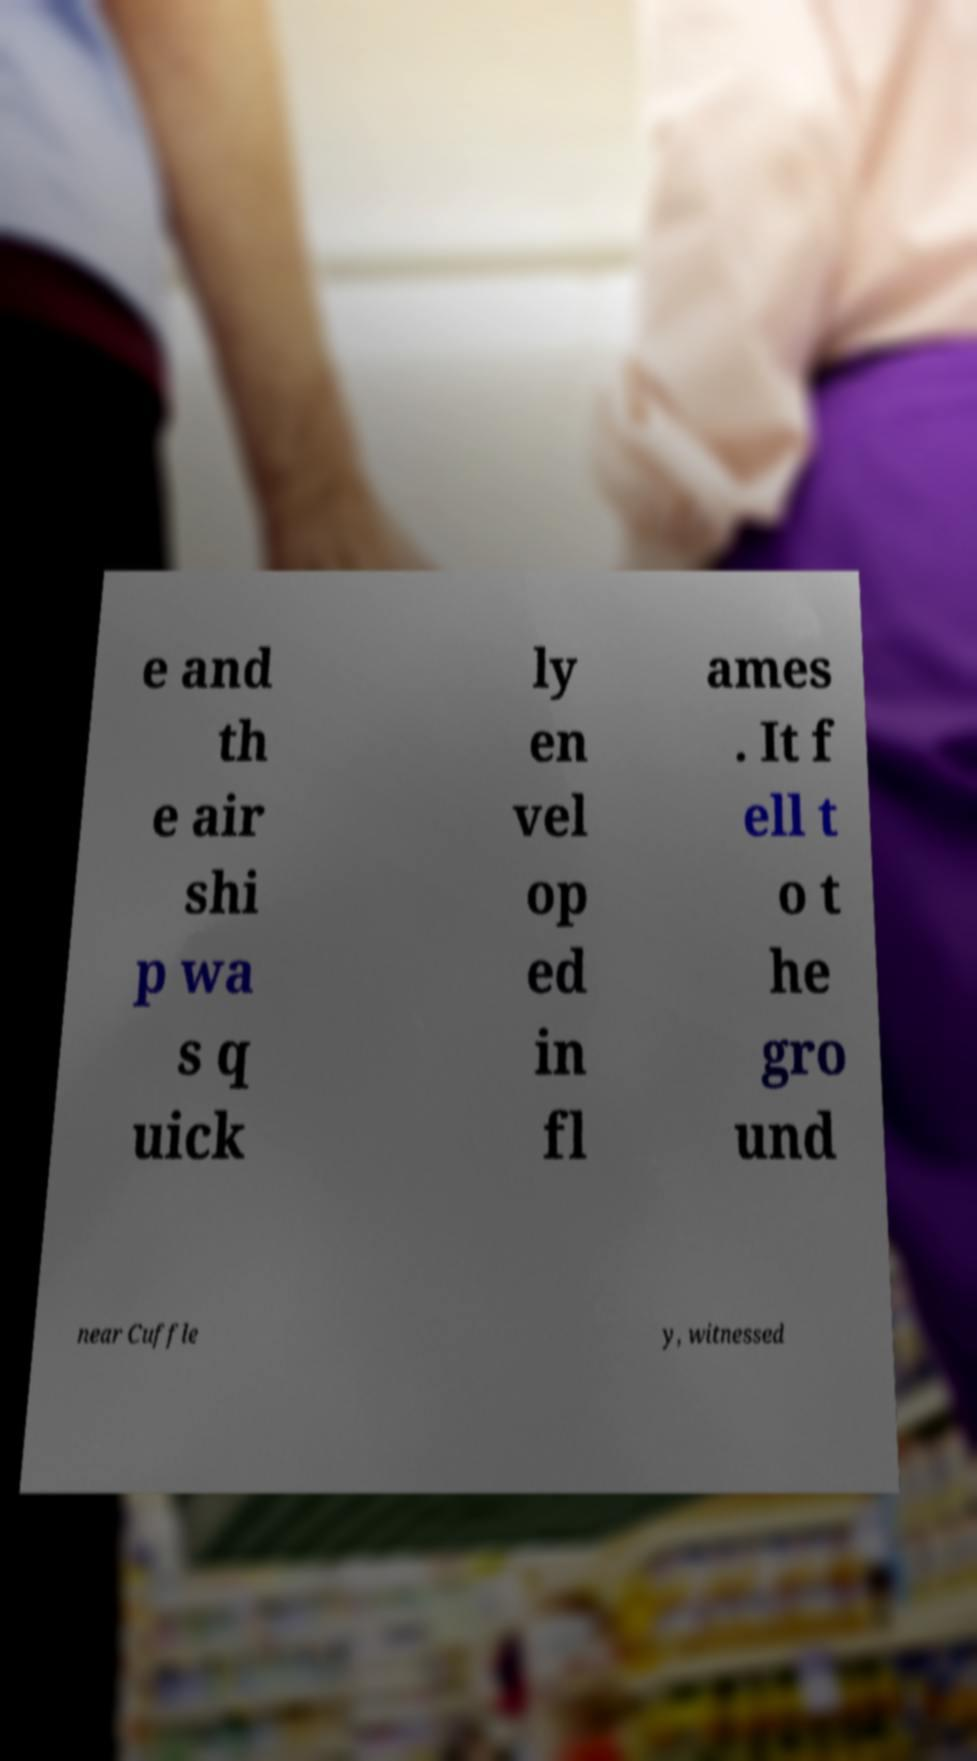For documentation purposes, I need the text within this image transcribed. Could you provide that? e and th e air shi p wa s q uick ly en vel op ed in fl ames . It f ell t o t he gro und near Cuffle y, witnessed 